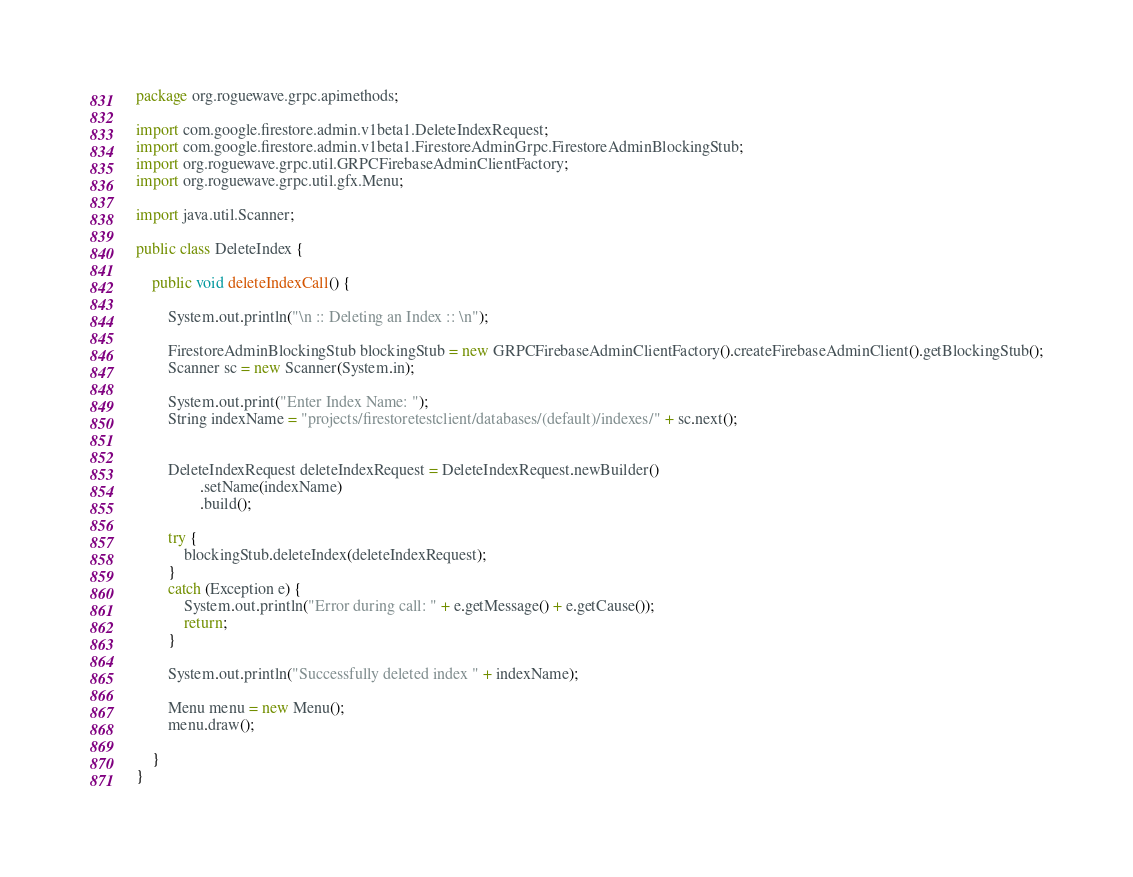<code> <loc_0><loc_0><loc_500><loc_500><_Java_>package org.roguewave.grpc.apimethods;

import com.google.firestore.admin.v1beta1.DeleteIndexRequest;
import com.google.firestore.admin.v1beta1.FirestoreAdminGrpc.FirestoreAdminBlockingStub;
import org.roguewave.grpc.util.GRPCFirebaseAdminClientFactory;
import org.roguewave.grpc.util.gfx.Menu;

import java.util.Scanner;

public class DeleteIndex {

    public void deleteIndexCall() {

        System.out.println("\n :: Deleting an Index :: \n");

        FirestoreAdminBlockingStub blockingStub = new GRPCFirebaseAdminClientFactory().createFirebaseAdminClient().getBlockingStub();
        Scanner sc = new Scanner(System.in);

        System.out.print("Enter Index Name: ");
        String indexName = "projects/firestoretestclient/databases/(default)/indexes/" + sc.next();


        DeleteIndexRequest deleteIndexRequest = DeleteIndexRequest.newBuilder()
                .setName(indexName)
                .build();

        try {
            blockingStub.deleteIndex(deleteIndexRequest);
        }
        catch (Exception e) {
            System.out.println("Error during call: " + e.getMessage() + e.getCause());
            return;
        }

        System.out.println("Successfully deleted index " + indexName);

        Menu menu = new Menu();
        menu.draw();

    }
}
</code> 